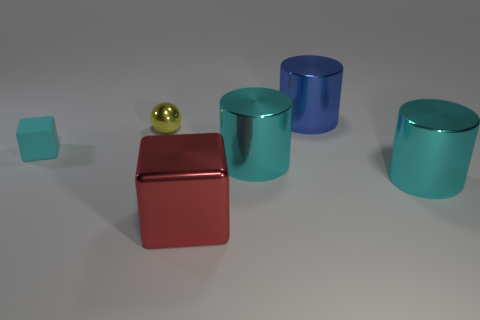There is a yellow sphere; what number of large shiny objects are in front of it?
Offer a terse response. 3. What color is the tiny object that is the same material as the large block?
Offer a terse response. Yellow. Is the size of the shiny cube the same as the shiny thing to the left of the large shiny cube?
Give a very brief answer. No. What size is the cyan cylinder to the left of the cylinder behind the cyan metallic cylinder to the left of the big blue object?
Offer a terse response. Large. How many metallic things are cyan cubes or tiny brown cubes?
Provide a succinct answer. 0. There is a metal cylinder that is to the right of the blue shiny thing; what color is it?
Give a very brief answer. Cyan. What shape is the blue thing that is the same size as the red cube?
Your response must be concise. Cylinder. There is a small matte object; does it have the same color as the shiny object behind the tiny yellow metal sphere?
Make the answer very short. No. How many things are cyan things to the left of the blue metal thing or big shiny objects that are on the right side of the red block?
Your answer should be very brief. 4. What is the material of the cube that is the same size as the blue metal object?
Offer a very short reply. Metal. 